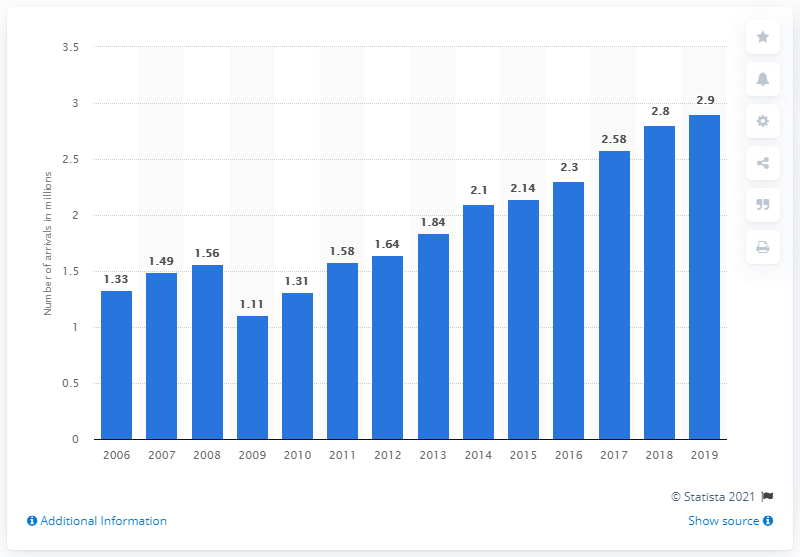Identify some key points in this picture. In 2019, a total of 2,900 tourists arrived at accommodation establishments in Latvia. Since 2009, there has been an increasing trend in arrivals. 